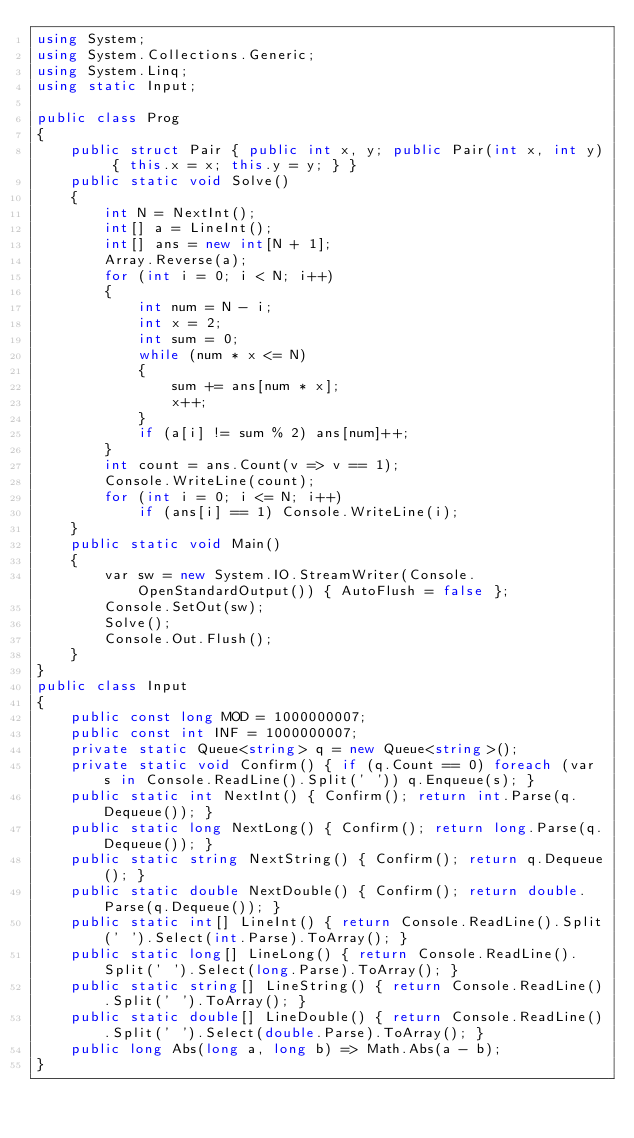Convert code to text. <code><loc_0><loc_0><loc_500><loc_500><_C#_>using System;
using System.Collections.Generic;
using System.Linq;
using static Input;

public class Prog
{
    public struct Pair { public int x, y; public Pair(int x, int y) { this.x = x; this.y = y; } }
    public static void Solve()
    {
        int N = NextInt();
        int[] a = LineInt();
        int[] ans = new int[N + 1];
        Array.Reverse(a);
        for (int i = 0; i < N; i++)
        {
            int num = N - i;
            int x = 2;
            int sum = 0;
            while (num * x <= N)
            {
                sum += ans[num * x];
                x++;
            }
            if (a[i] != sum % 2) ans[num]++;
        }
        int count = ans.Count(v => v == 1);
        Console.WriteLine(count);
        for (int i = 0; i <= N; i++)
            if (ans[i] == 1) Console.WriteLine(i);
    }
    public static void Main()
    {
        var sw = new System.IO.StreamWriter(Console.OpenStandardOutput()) { AutoFlush = false };
        Console.SetOut(sw);
        Solve();
        Console.Out.Flush();
    }
}
public class Input
{
    public const long MOD = 1000000007;
    public const int INF = 1000000007;
    private static Queue<string> q = new Queue<string>();
    private static void Confirm() { if (q.Count == 0) foreach (var s in Console.ReadLine().Split(' ')) q.Enqueue(s); }
    public static int NextInt() { Confirm(); return int.Parse(q.Dequeue()); }
    public static long NextLong() { Confirm(); return long.Parse(q.Dequeue()); }
    public static string NextString() { Confirm(); return q.Dequeue(); }
    public static double NextDouble() { Confirm(); return double.Parse(q.Dequeue()); }
    public static int[] LineInt() { return Console.ReadLine().Split(' ').Select(int.Parse).ToArray(); }
    public static long[] LineLong() { return Console.ReadLine().Split(' ').Select(long.Parse).ToArray(); }
    public static string[] LineString() { return Console.ReadLine().Split(' ').ToArray(); }
    public static double[] LineDouble() { return Console.ReadLine().Split(' ').Select(double.Parse).ToArray(); }
    public long Abs(long a, long b) => Math.Abs(a - b);
}
</code> 